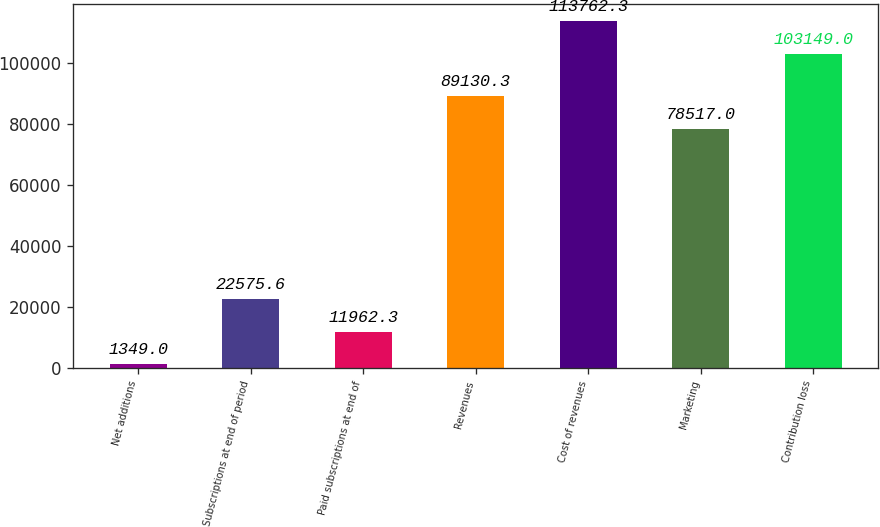Convert chart to OTSL. <chart><loc_0><loc_0><loc_500><loc_500><bar_chart><fcel>Net additions<fcel>Subscriptions at end of period<fcel>Paid subscriptions at end of<fcel>Revenues<fcel>Cost of revenues<fcel>Marketing<fcel>Contribution loss<nl><fcel>1349<fcel>22575.6<fcel>11962.3<fcel>89130.3<fcel>113762<fcel>78517<fcel>103149<nl></chart> 